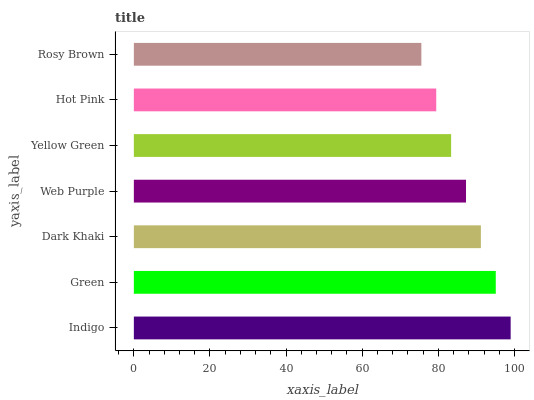Is Rosy Brown the minimum?
Answer yes or no. Yes. Is Indigo the maximum?
Answer yes or no. Yes. Is Green the minimum?
Answer yes or no. No. Is Green the maximum?
Answer yes or no. No. Is Indigo greater than Green?
Answer yes or no. Yes. Is Green less than Indigo?
Answer yes or no. Yes. Is Green greater than Indigo?
Answer yes or no. No. Is Indigo less than Green?
Answer yes or no. No. Is Web Purple the high median?
Answer yes or no. Yes. Is Web Purple the low median?
Answer yes or no. Yes. Is Hot Pink the high median?
Answer yes or no. No. Is Rosy Brown the low median?
Answer yes or no. No. 